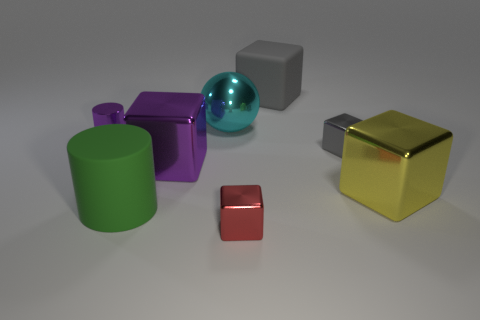The metal thing that is the same color as the large matte block is what shape?
Your answer should be compact. Cube. What number of things are either large metallic objects that are in front of the small purple object or big green rubber cylinders?
Your response must be concise. 3. There is a gray cube that is made of the same material as the big cyan object; what is its size?
Give a very brief answer. Small. Do the purple cylinder and the metallic object in front of the big yellow object have the same size?
Your answer should be compact. Yes. What is the color of the large block that is both to the right of the cyan metal thing and in front of the ball?
Ensure brevity in your answer.  Yellow. What number of things are big things that are behind the small gray shiny thing or big matte things left of the red metallic object?
Your answer should be compact. 3. What is the color of the small object in front of the large shiny block on the right side of the gray object behind the large cyan sphere?
Make the answer very short. Red. Is there a tiny purple metallic thing of the same shape as the big green rubber thing?
Provide a succinct answer. Yes. How many large yellow objects are there?
Offer a very short reply. 1. There is a gray matte object; what shape is it?
Make the answer very short. Cube. 